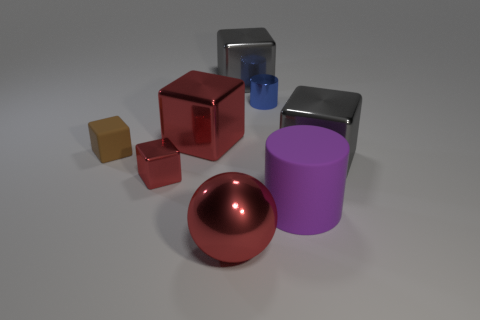There is a large red object behind the purple cylinder; what shape is it?
Provide a succinct answer. Cube. What color is the large metallic object to the left of the big ball left of the rubber cylinder?
Your answer should be very brief. Red. What color is the other object that is the same shape as the blue metallic thing?
Give a very brief answer. Purple. What number of large spheres are the same color as the tiny matte object?
Your answer should be compact. 0. There is a big rubber cylinder; is its color the same as the small thing that is in front of the small rubber thing?
Your response must be concise. No. What is the shape of the object that is in front of the blue cylinder and behind the tiny brown matte object?
Your answer should be compact. Cube. What material is the big gray block that is behind the gray block in front of the metal thing behind the tiny blue cylinder?
Your answer should be compact. Metal. Is the number of big cylinders left of the blue metallic cylinder greater than the number of matte things to the right of the brown matte thing?
Provide a succinct answer. No. How many large balls are made of the same material as the tiny blue object?
Your answer should be compact. 1. There is a small metal object in front of the tiny brown matte object; is its shape the same as the big red metallic object behind the tiny brown block?
Give a very brief answer. Yes. 